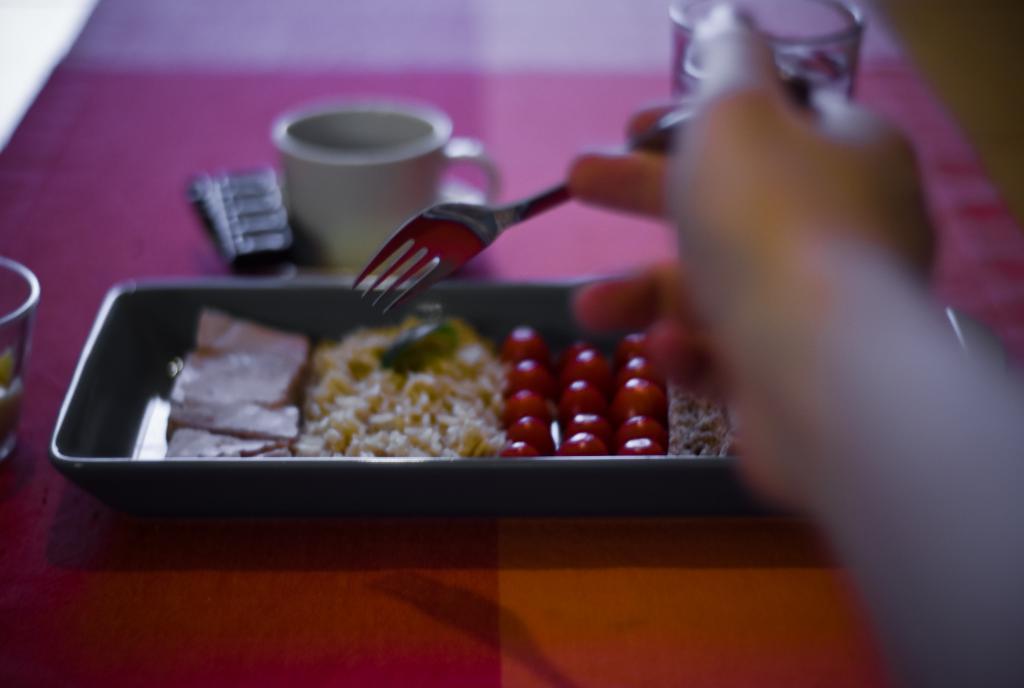Could you give a brief overview of what you see in this image? The bottom of the image there is a table with a cup, a glass of water, a bowl and a box with a few food items on it. On the right side of the image there is a hand of a person holding a fork. 